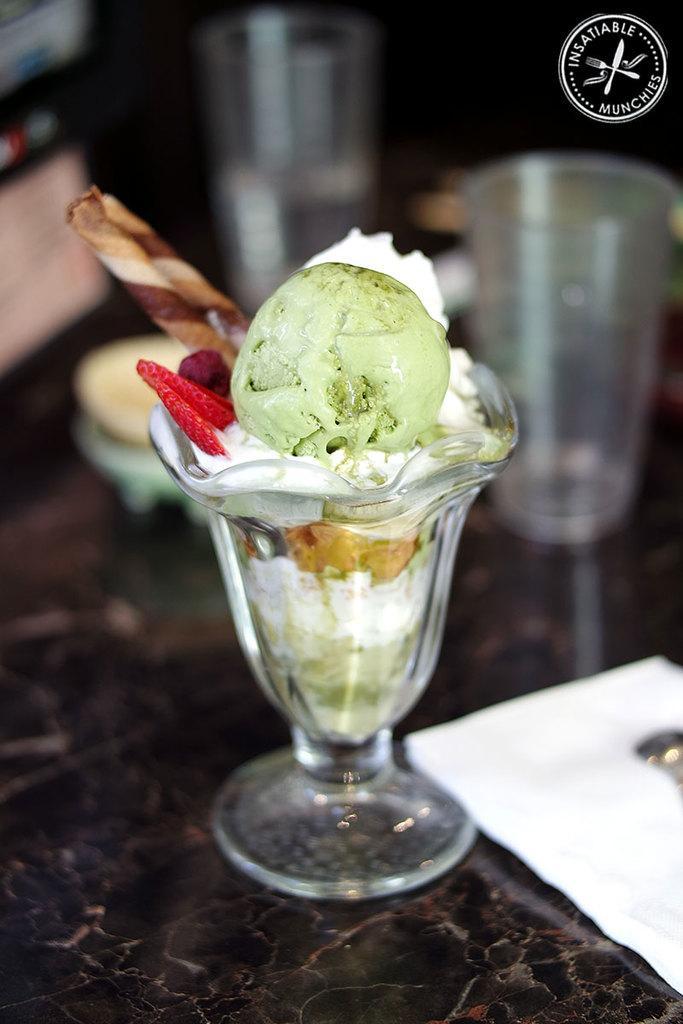In one or two sentences, can you explain what this image depicts? It is an ice-cream in a glass jar, on the right side there is a glass. 